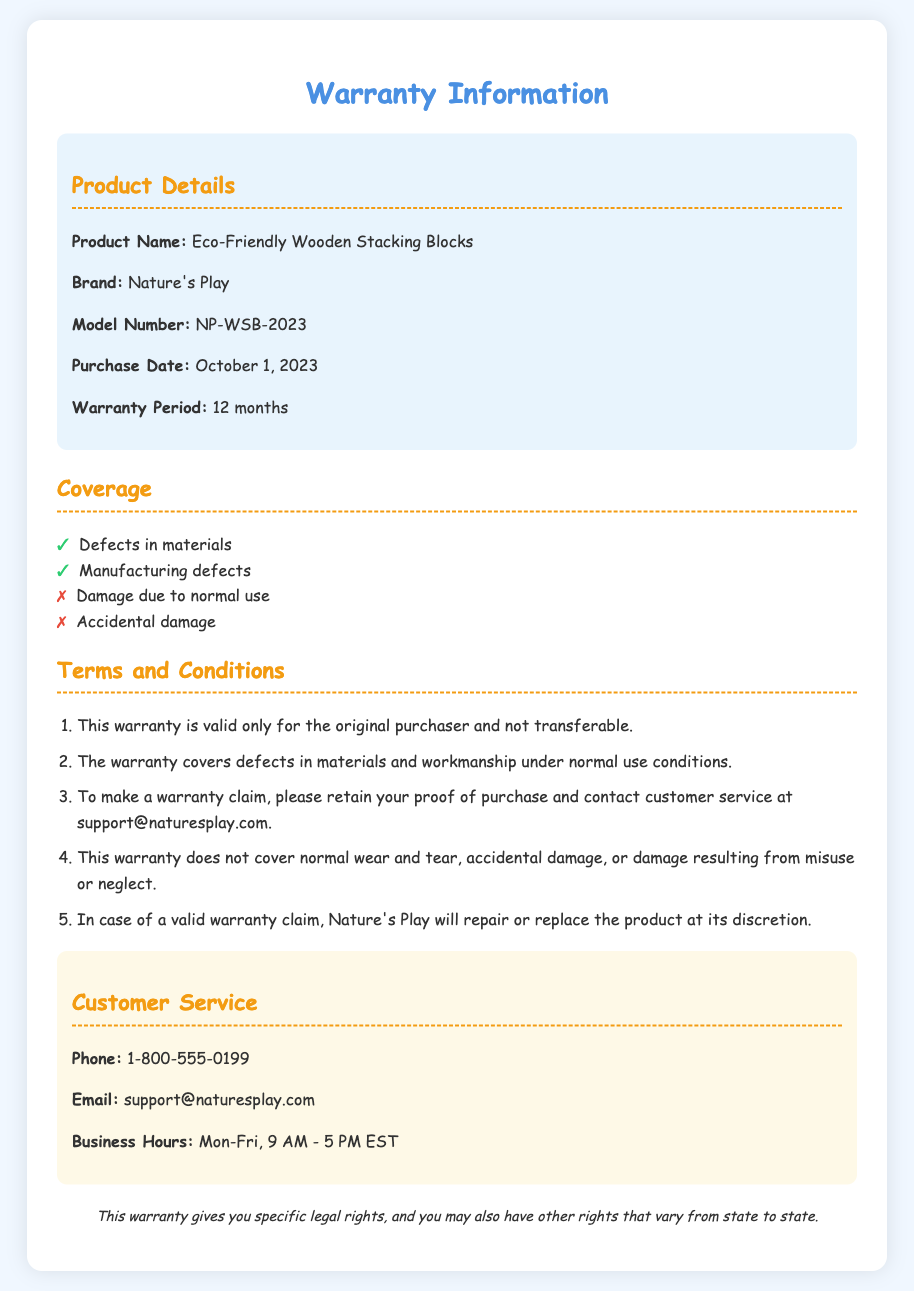What is the product name? The product name is stated clearly in the document.
Answer: Eco-Friendly Wooden Stacking Blocks What is the warranty period? The warranty period is indicated in the product details section of the document.
Answer: 12 months What is the purchase date? The purchase date is listed in the product details section.
Answer: October 1, 2023 What does the warranty cover? The coverage list outlines what is covered by the warranty.
Answer: Defects in materials, Manufacturing defects What is not covered by the warranty? The coverage list highlights what is excluded from the warranty.
Answer: Damage due to normal use, Accidental damage Who is the manufacturer of the product? The brand name in the document identifies the manufacturer.
Answer: Nature's Play What should you retain for a warranty claim? The terms specify what documentation is needed to support a warranty claim.
Answer: Proof of purchase What will Nature's Play do in case of a valid warranty claim? The terms clarify the action taken on a valid warranty claim.
Answer: Repair or replace the product What is the customer service email? The customer service section provides contact information for inquiries.
Answer: support@naturesplay.com What is the business hours for customer service? The contact section states the operating hours for customer service.
Answer: Mon-Fri, 9 AM - 5 PM EST 